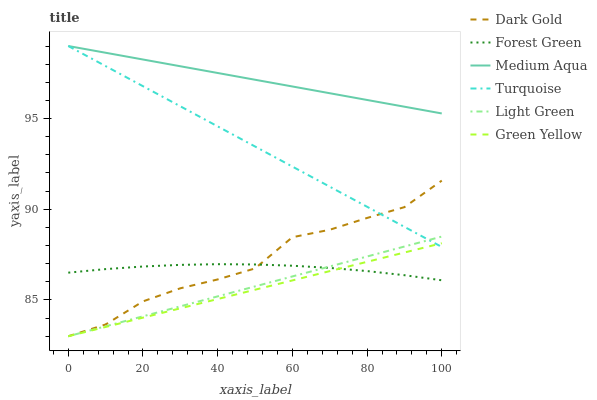Does Dark Gold have the minimum area under the curve?
Answer yes or no. No. Does Dark Gold have the maximum area under the curve?
Answer yes or no. No. Is Forest Green the smoothest?
Answer yes or no. No. Is Forest Green the roughest?
Answer yes or no. No. Does Forest Green have the lowest value?
Answer yes or no. No. Does Dark Gold have the highest value?
Answer yes or no. No. Is Forest Green less than Turquoise?
Answer yes or no. Yes. Is Medium Aqua greater than Green Yellow?
Answer yes or no. Yes. Does Forest Green intersect Turquoise?
Answer yes or no. No. 